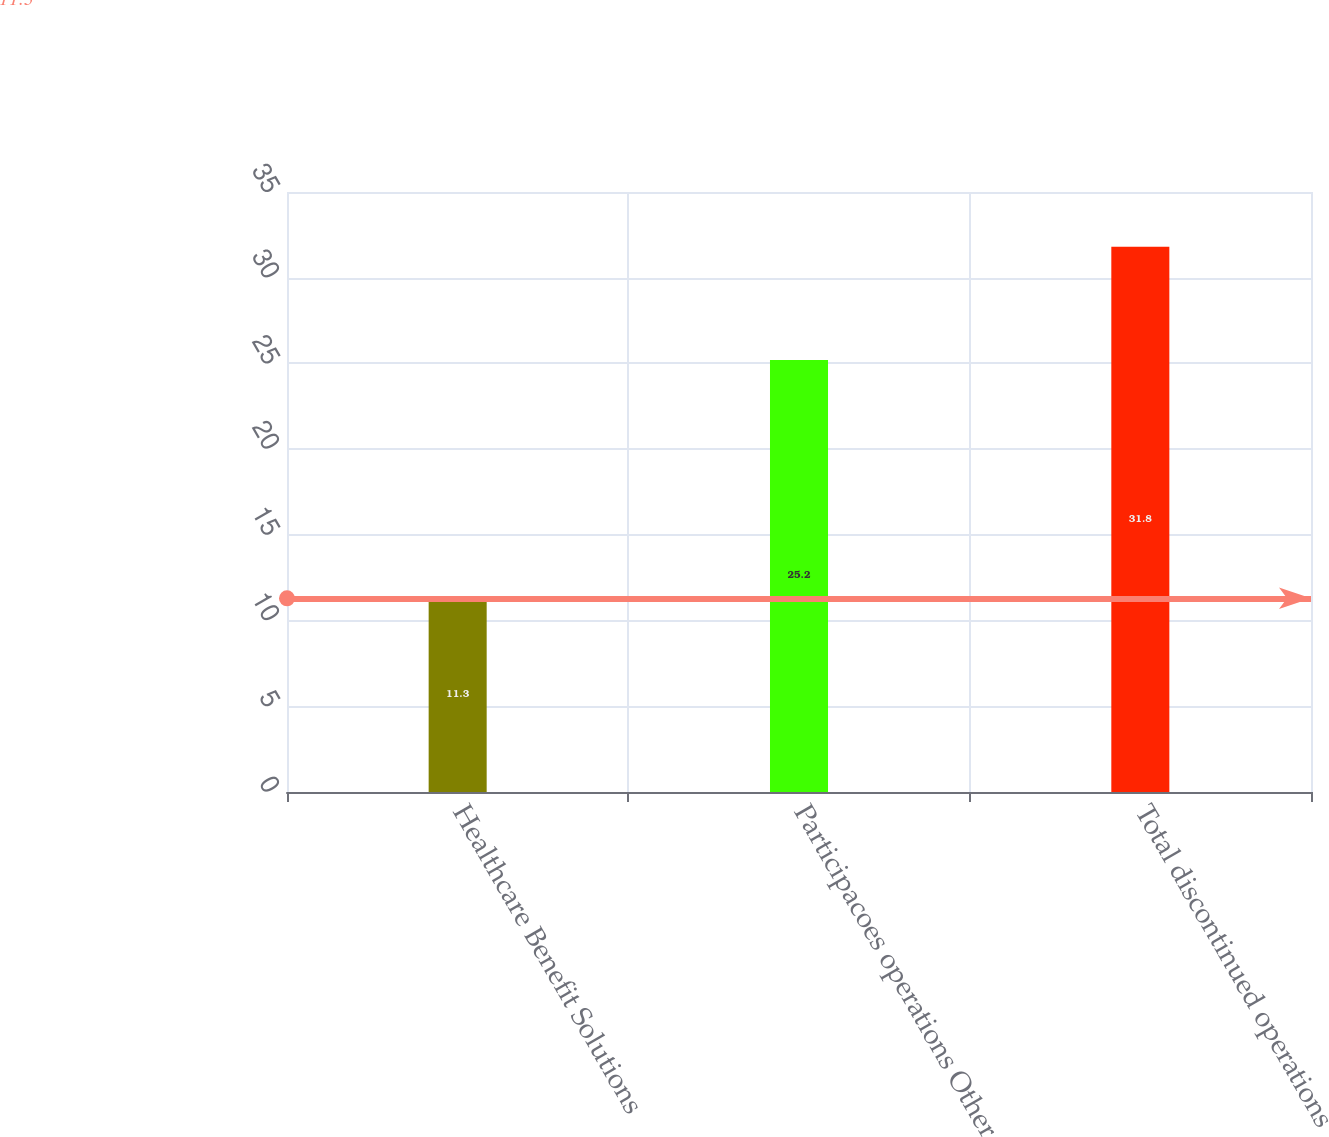Convert chart to OTSL. <chart><loc_0><loc_0><loc_500><loc_500><bar_chart><fcel>Healthcare Benefit Solutions<fcel>Participacoes operations Other<fcel>Total discontinued operations<nl><fcel>11.3<fcel>25.2<fcel>31.8<nl></chart> 